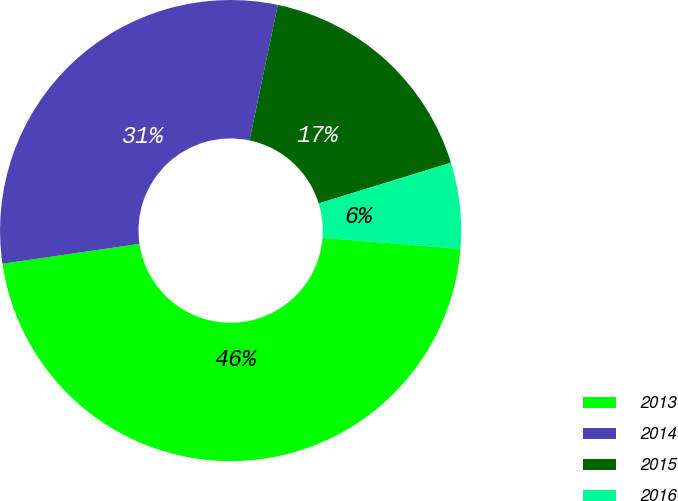Convert chart. <chart><loc_0><loc_0><loc_500><loc_500><pie_chart><fcel>2013<fcel>2014<fcel>2015<fcel>2016<nl><fcel>46.44%<fcel>30.58%<fcel>16.96%<fcel>6.01%<nl></chart> 